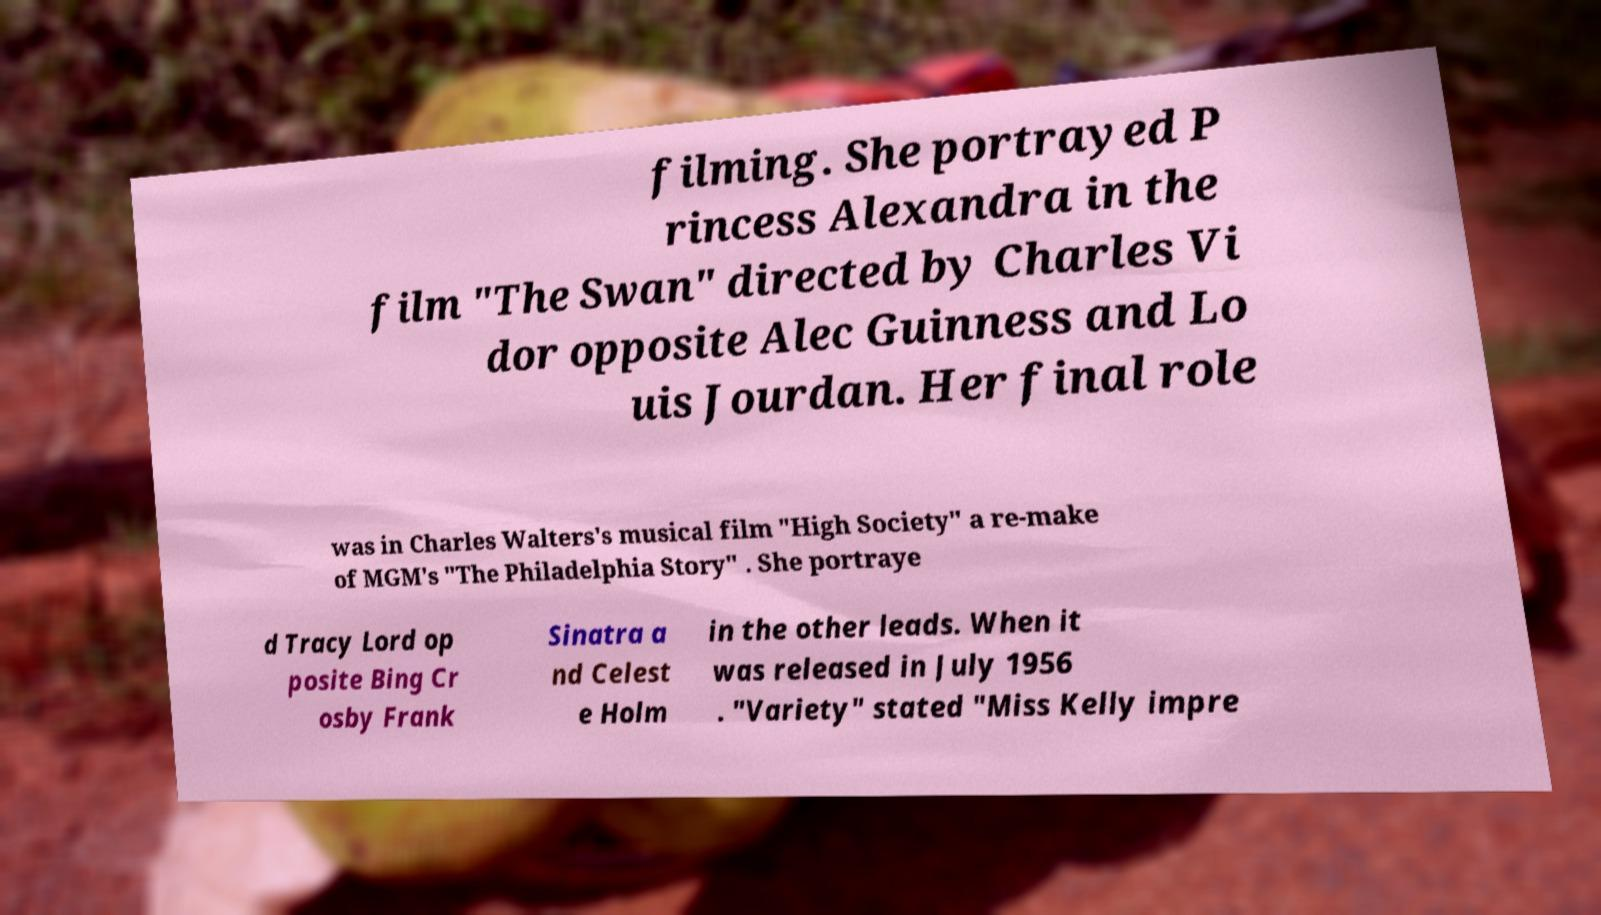I need the written content from this picture converted into text. Can you do that? filming. She portrayed P rincess Alexandra in the film "The Swan" directed by Charles Vi dor opposite Alec Guinness and Lo uis Jourdan. Her final role was in Charles Walters's musical film "High Society" a re-make of MGM's "The Philadelphia Story" . She portraye d Tracy Lord op posite Bing Cr osby Frank Sinatra a nd Celest e Holm in the other leads. When it was released in July 1956 . "Variety" stated "Miss Kelly impre 